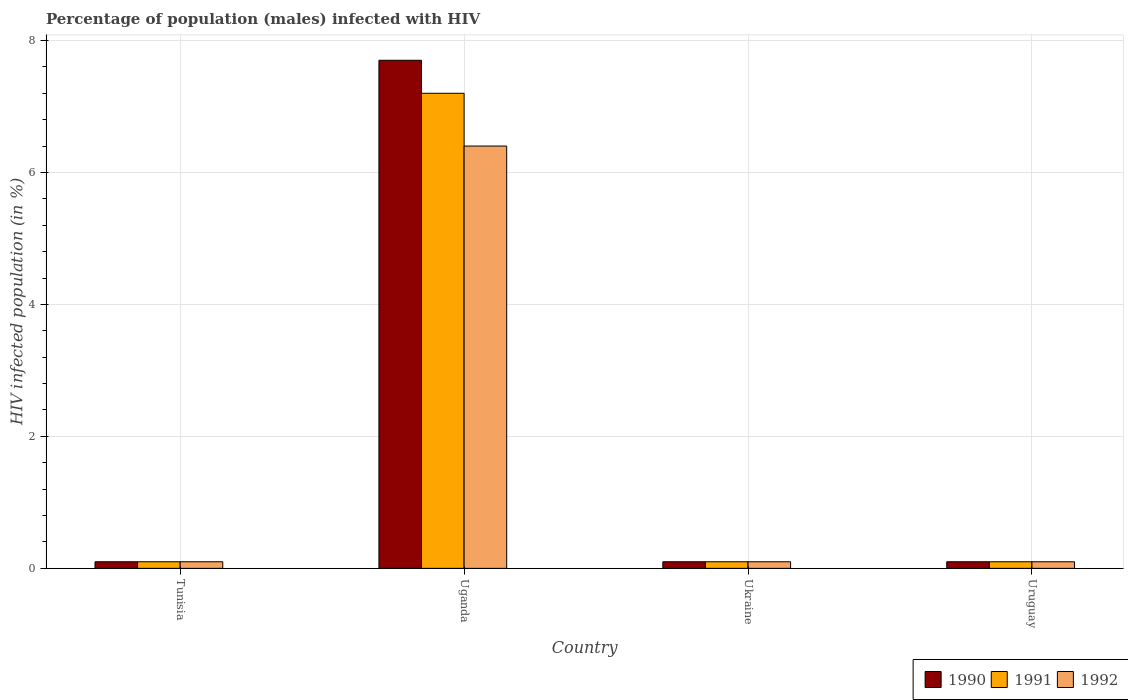How many different coloured bars are there?
Keep it short and to the point. 3. How many groups of bars are there?
Your response must be concise. 4. Are the number of bars on each tick of the X-axis equal?
Provide a succinct answer. Yes. How many bars are there on the 3rd tick from the left?
Keep it short and to the point. 3. What is the label of the 3rd group of bars from the left?
Your answer should be very brief. Ukraine. In how many cases, is the number of bars for a given country not equal to the number of legend labels?
Make the answer very short. 0. What is the percentage of HIV infected male population in 1990 in Tunisia?
Provide a succinct answer. 0.1. Across all countries, what is the minimum percentage of HIV infected male population in 1990?
Provide a succinct answer. 0.1. In which country was the percentage of HIV infected male population in 1991 maximum?
Offer a terse response. Uganda. In which country was the percentage of HIV infected male population in 1990 minimum?
Make the answer very short. Tunisia. What is the total percentage of HIV infected male population in 1992 in the graph?
Your answer should be compact. 6.7. What is the difference between the percentage of HIV infected male population in 1991 in Uganda and that in Ukraine?
Keep it short and to the point. 7.1. What is the difference between the percentage of HIV infected male population in 1990 in Uganda and the percentage of HIV infected male population in 1991 in Ukraine?
Your answer should be very brief. 7.6. What is the average percentage of HIV infected male population in 1990 per country?
Make the answer very short. 2. In how many countries, is the percentage of HIV infected male population in 1990 greater than 6.8 %?
Ensure brevity in your answer.  1. What is the difference between the highest and the second highest percentage of HIV infected male population in 1991?
Provide a short and direct response. -7.1. What is the difference between the highest and the lowest percentage of HIV infected male population in 1991?
Ensure brevity in your answer.  7.1. In how many countries, is the percentage of HIV infected male population in 1992 greater than the average percentage of HIV infected male population in 1992 taken over all countries?
Make the answer very short. 1. Is the sum of the percentage of HIV infected male population in 1992 in Tunisia and Ukraine greater than the maximum percentage of HIV infected male population in 1990 across all countries?
Keep it short and to the point. No. What does the 1st bar from the left in Uganda represents?
Your response must be concise. 1990. What does the 3rd bar from the right in Ukraine represents?
Make the answer very short. 1990. Is it the case that in every country, the sum of the percentage of HIV infected male population in 1992 and percentage of HIV infected male population in 1991 is greater than the percentage of HIV infected male population in 1990?
Offer a terse response. Yes. How many bars are there?
Your answer should be compact. 12. Are all the bars in the graph horizontal?
Your response must be concise. No. What is the difference between two consecutive major ticks on the Y-axis?
Give a very brief answer. 2. Are the values on the major ticks of Y-axis written in scientific E-notation?
Keep it short and to the point. No. Does the graph contain any zero values?
Provide a short and direct response. No. Does the graph contain grids?
Make the answer very short. Yes. How many legend labels are there?
Provide a succinct answer. 3. How are the legend labels stacked?
Your answer should be very brief. Horizontal. What is the title of the graph?
Offer a terse response. Percentage of population (males) infected with HIV. What is the label or title of the X-axis?
Give a very brief answer. Country. What is the label or title of the Y-axis?
Provide a succinct answer. HIV infected population (in %). What is the HIV infected population (in %) of 1991 in Tunisia?
Ensure brevity in your answer.  0.1. What is the HIV infected population (in %) of 1990 in Uganda?
Your answer should be compact. 7.7. What is the HIV infected population (in %) in 1990 in Ukraine?
Your answer should be very brief. 0.1. What is the HIV infected population (in %) of 1991 in Ukraine?
Provide a succinct answer. 0.1. What is the HIV infected population (in %) of 1990 in Uruguay?
Your answer should be very brief. 0.1. Across all countries, what is the maximum HIV infected population (in %) of 1991?
Your answer should be very brief. 7.2. Across all countries, what is the maximum HIV infected population (in %) of 1992?
Give a very brief answer. 6.4. Across all countries, what is the minimum HIV infected population (in %) in 1990?
Offer a terse response. 0.1. Across all countries, what is the minimum HIV infected population (in %) of 1991?
Give a very brief answer. 0.1. Across all countries, what is the minimum HIV infected population (in %) of 1992?
Offer a terse response. 0.1. What is the total HIV infected population (in %) in 1991 in the graph?
Your answer should be very brief. 7.5. What is the total HIV infected population (in %) of 1992 in the graph?
Your answer should be compact. 6.7. What is the difference between the HIV infected population (in %) of 1990 in Tunisia and that in Uganda?
Your answer should be very brief. -7.6. What is the difference between the HIV infected population (in %) in 1992 in Tunisia and that in Uganda?
Your response must be concise. -6.3. What is the difference between the HIV infected population (in %) of 1991 in Tunisia and that in Ukraine?
Ensure brevity in your answer.  0. What is the difference between the HIV infected population (in %) of 1992 in Tunisia and that in Ukraine?
Ensure brevity in your answer.  0. What is the difference between the HIV infected population (in %) of 1990 in Tunisia and that in Uruguay?
Ensure brevity in your answer.  0. What is the difference between the HIV infected population (in %) in 1990 in Uganda and that in Ukraine?
Give a very brief answer. 7.6. What is the difference between the HIV infected population (in %) of 1991 in Uganda and that in Uruguay?
Provide a succinct answer. 7.1. What is the difference between the HIV infected population (in %) of 1992 in Uganda and that in Uruguay?
Ensure brevity in your answer.  6.3. What is the difference between the HIV infected population (in %) of 1990 in Ukraine and that in Uruguay?
Your answer should be very brief. 0. What is the difference between the HIV infected population (in %) of 1991 in Ukraine and that in Uruguay?
Offer a very short reply. 0. What is the difference between the HIV infected population (in %) in 1990 in Tunisia and the HIV infected population (in %) in 1991 in Uganda?
Provide a short and direct response. -7.1. What is the difference between the HIV infected population (in %) of 1990 in Tunisia and the HIV infected population (in %) of 1992 in Ukraine?
Offer a very short reply. 0. What is the difference between the HIV infected population (in %) of 1991 in Tunisia and the HIV infected population (in %) of 1992 in Ukraine?
Give a very brief answer. 0. What is the difference between the HIV infected population (in %) in 1990 in Uganda and the HIV infected population (in %) in 1991 in Uruguay?
Give a very brief answer. 7.6. What is the difference between the HIV infected population (in %) of 1991 in Uganda and the HIV infected population (in %) of 1992 in Uruguay?
Provide a succinct answer. 7.1. What is the difference between the HIV infected population (in %) in 1990 in Ukraine and the HIV infected population (in %) in 1992 in Uruguay?
Make the answer very short. 0. What is the difference between the HIV infected population (in %) in 1991 in Ukraine and the HIV infected population (in %) in 1992 in Uruguay?
Your answer should be very brief. 0. What is the average HIV infected population (in %) of 1991 per country?
Keep it short and to the point. 1.88. What is the average HIV infected population (in %) of 1992 per country?
Keep it short and to the point. 1.68. What is the difference between the HIV infected population (in %) of 1991 and HIV infected population (in %) of 1992 in Tunisia?
Give a very brief answer. 0. What is the difference between the HIV infected population (in %) of 1990 and HIV infected population (in %) of 1991 in Uganda?
Provide a succinct answer. 0.5. What is the difference between the HIV infected population (in %) in 1990 and HIV infected population (in %) in 1992 in Uganda?
Your answer should be very brief. 1.3. What is the difference between the HIV infected population (in %) of 1991 and HIV infected population (in %) of 1992 in Uganda?
Ensure brevity in your answer.  0.8. What is the difference between the HIV infected population (in %) of 1990 and HIV infected population (in %) of 1991 in Uruguay?
Offer a terse response. 0. What is the difference between the HIV infected population (in %) of 1990 and HIV infected population (in %) of 1992 in Uruguay?
Provide a short and direct response. 0. What is the ratio of the HIV infected population (in %) in 1990 in Tunisia to that in Uganda?
Your response must be concise. 0.01. What is the ratio of the HIV infected population (in %) in 1991 in Tunisia to that in Uganda?
Ensure brevity in your answer.  0.01. What is the ratio of the HIV infected population (in %) in 1992 in Tunisia to that in Uganda?
Ensure brevity in your answer.  0.02. What is the ratio of the HIV infected population (in %) of 1991 in Tunisia to that in Ukraine?
Provide a succinct answer. 1. What is the ratio of the HIV infected population (in %) of 1992 in Tunisia to that in Ukraine?
Make the answer very short. 1. What is the ratio of the HIV infected population (in %) in 1990 in Tunisia to that in Uruguay?
Provide a succinct answer. 1. What is the ratio of the HIV infected population (in %) of 1991 in Tunisia to that in Uruguay?
Your response must be concise. 1. What is the ratio of the HIV infected population (in %) in 1992 in Tunisia to that in Uruguay?
Keep it short and to the point. 1. What is the ratio of the HIV infected population (in %) of 1990 in Uganda to that in Ukraine?
Your answer should be very brief. 77. What is the ratio of the HIV infected population (in %) in 1992 in Uganda to that in Ukraine?
Ensure brevity in your answer.  64. What is the ratio of the HIV infected population (in %) of 1990 in Uganda to that in Uruguay?
Ensure brevity in your answer.  77. What is the ratio of the HIV infected population (in %) of 1991 in Uganda to that in Uruguay?
Provide a succinct answer. 72. What is the ratio of the HIV infected population (in %) in 1992 in Uganda to that in Uruguay?
Your response must be concise. 64. What is the ratio of the HIV infected population (in %) in 1990 in Ukraine to that in Uruguay?
Provide a succinct answer. 1. What is the ratio of the HIV infected population (in %) in 1991 in Ukraine to that in Uruguay?
Provide a succinct answer. 1. What is the ratio of the HIV infected population (in %) in 1992 in Ukraine to that in Uruguay?
Provide a succinct answer. 1. What is the difference between the highest and the second highest HIV infected population (in %) of 1990?
Provide a succinct answer. 7.6. What is the difference between the highest and the second highest HIV infected population (in %) in 1991?
Your answer should be very brief. 7.1. What is the difference between the highest and the second highest HIV infected population (in %) of 1992?
Provide a short and direct response. 6.3. What is the difference between the highest and the lowest HIV infected population (in %) in 1990?
Your response must be concise. 7.6. What is the difference between the highest and the lowest HIV infected population (in %) in 1991?
Your answer should be compact. 7.1. 